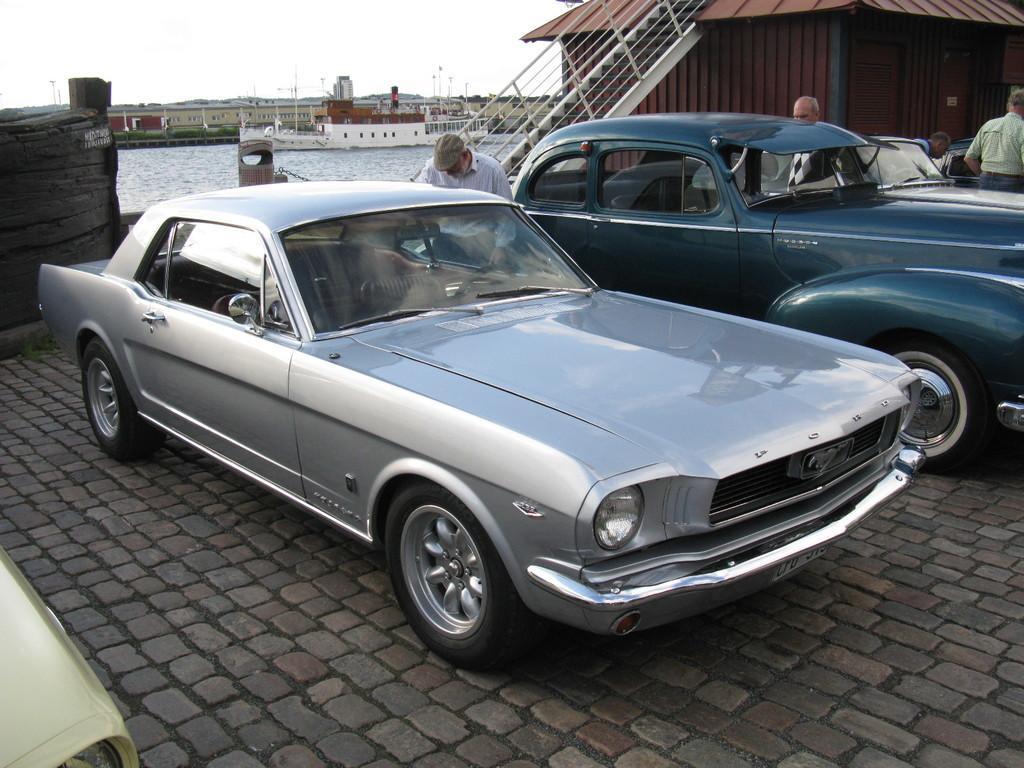Describe this image in one or two sentences. In the foreground of this image, there are four cars on the pavement and also persons standing. Behind them, there are stairs, a hut, bollard, water, ship on the water, few buildings and the sky. 